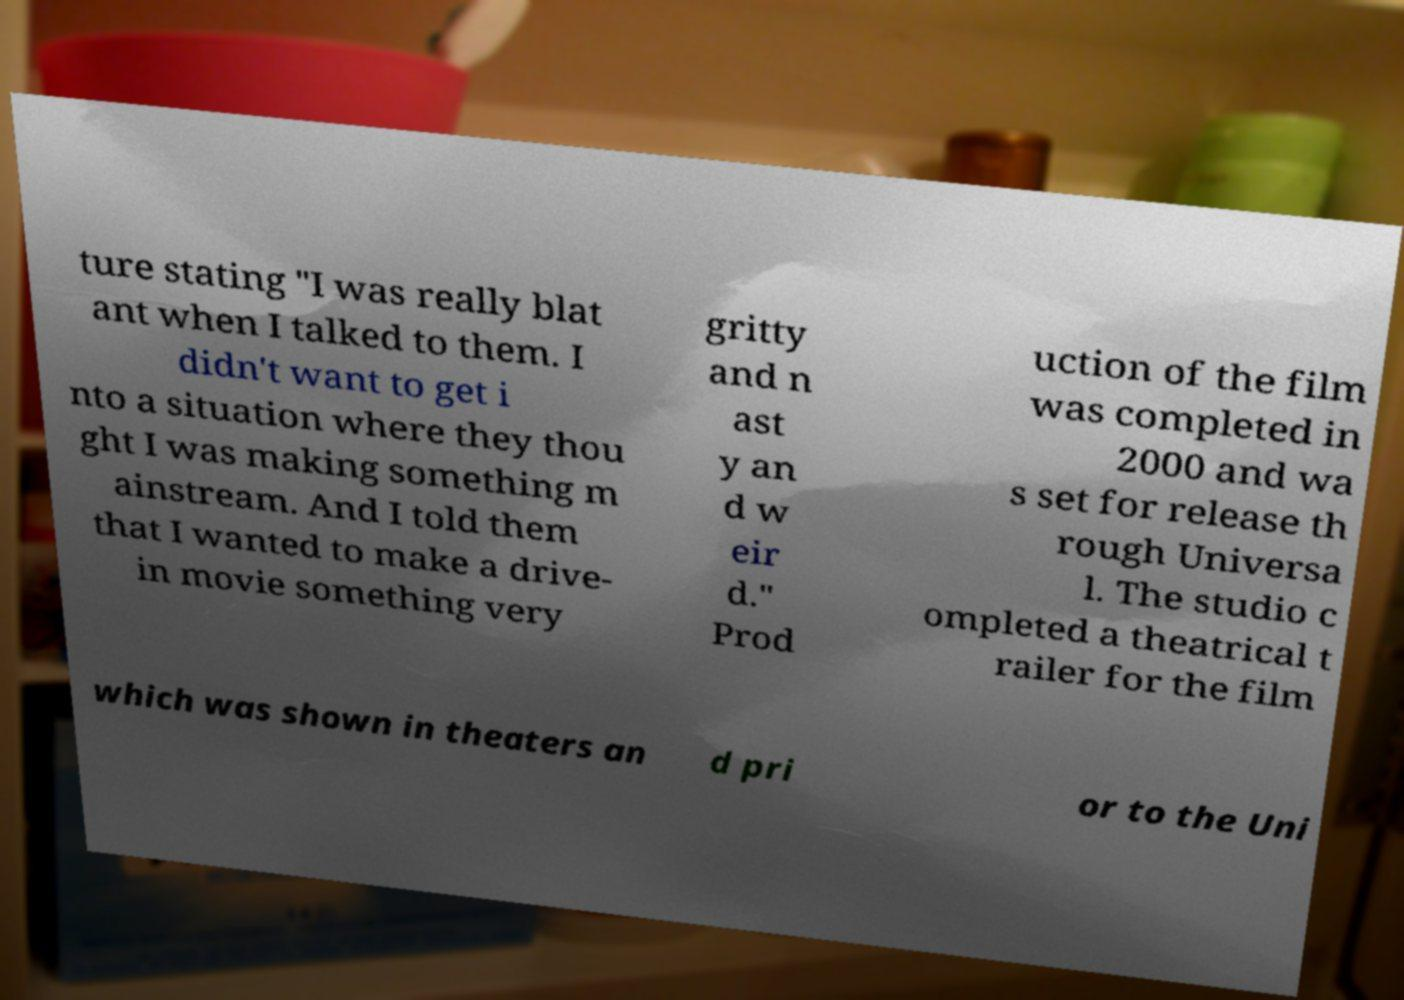Can you accurately transcribe the text from the provided image for me? ture stating "I was really blat ant when I talked to them. I didn't want to get i nto a situation where they thou ght I was making something m ainstream. And I told them that I wanted to make a drive- in movie something very gritty and n ast y an d w eir d." Prod uction of the film was completed in 2000 and wa s set for release th rough Universa l. The studio c ompleted a theatrical t railer for the film which was shown in theaters an d pri or to the Uni 